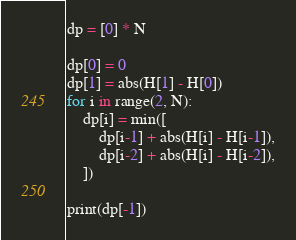Convert code to text. <code><loc_0><loc_0><loc_500><loc_500><_Python_>dp = [0] * N

dp[0] = 0
dp[1] = abs(H[1] - H[0])
for i in range(2, N):
    dp[i] = min([
        dp[i-1] + abs(H[i] - H[i-1]),
        dp[i-2] + abs(H[i] - H[i-2]),
    ])
    
print(dp[-1])</code> 